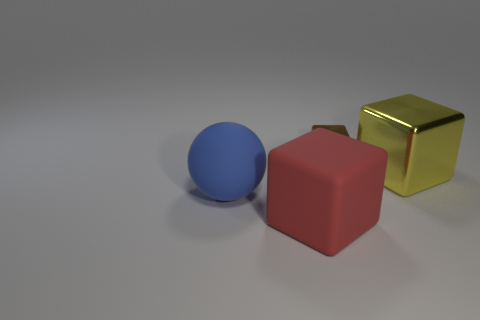Subtract all big yellow blocks. How many blocks are left? 2 Add 2 red cubes. How many objects exist? 6 Subtract all balls. How many objects are left? 3 Add 1 tiny purple matte balls. How many tiny purple matte balls exist? 1 Subtract 0 gray cubes. How many objects are left? 4 Subtract all tiny red blocks. Subtract all large matte objects. How many objects are left? 2 Add 3 metallic objects. How many metallic objects are left? 5 